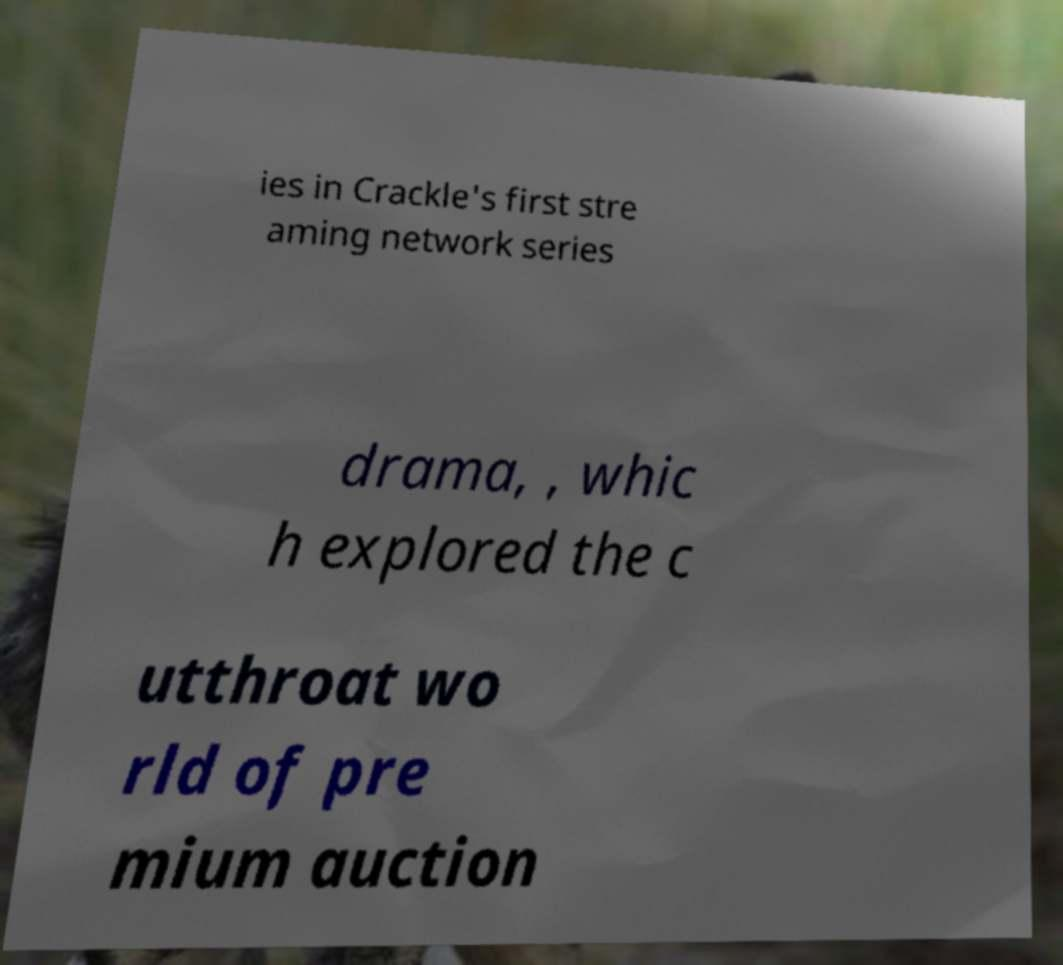Can you accurately transcribe the text from the provided image for me? ies in Crackle's first stre aming network series drama, , whic h explored the c utthroat wo rld of pre mium auction 